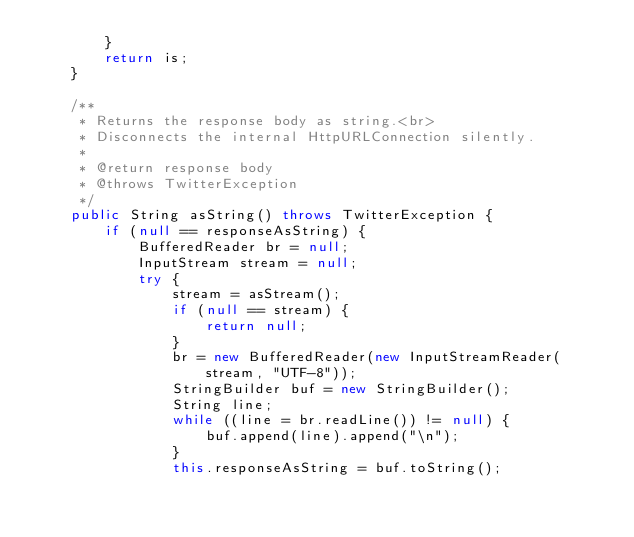<code> <loc_0><loc_0><loc_500><loc_500><_Java_>        }
        return is;
    }

    /**
     * Returns the response body as string.<br>
     * Disconnects the internal HttpURLConnection silently.
     *
     * @return response body
     * @throws TwitterException
     */
    public String asString() throws TwitterException {
        if (null == responseAsString) {
            BufferedReader br = null;
            InputStream stream = null;
            try {
                stream = asStream();
                if (null == stream) {
                    return null;
                }
                br = new BufferedReader(new InputStreamReader(stream, "UTF-8"));
                StringBuilder buf = new StringBuilder();
                String line;
                while ((line = br.readLine()) != null) {
                    buf.append(line).append("\n");
                }
                this.responseAsString = buf.toString();</code> 